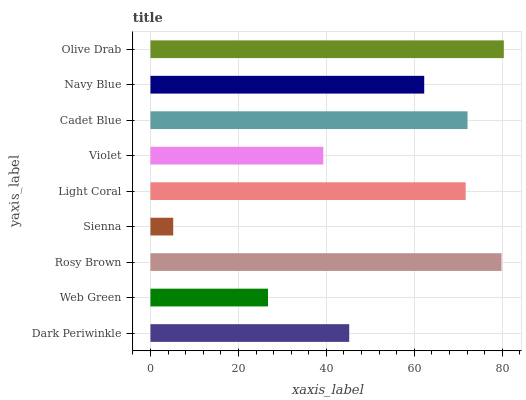Is Sienna the minimum?
Answer yes or no. Yes. Is Olive Drab the maximum?
Answer yes or no. Yes. Is Web Green the minimum?
Answer yes or no. No. Is Web Green the maximum?
Answer yes or no. No. Is Dark Periwinkle greater than Web Green?
Answer yes or no. Yes. Is Web Green less than Dark Periwinkle?
Answer yes or no. Yes. Is Web Green greater than Dark Periwinkle?
Answer yes or no. No. Is Dark Periwinkle less than Web Green?
Answer yes or no. No. Is Navy Blue the high median?
Answer yes or no. Yes. Is Navy Blue the low median?
Answer yes or no. Yes. Is Violet the high median?
Answer yes or no. No. Is Light Coral the low median?
Answer yes or no. No. 